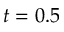Convert formula to latex. <formula><loc_0><loc_0><loc_500><loc_500>t = 0 . 5</formula> 